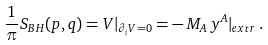<formula> <loc_0><loc_0><loc_500><loc_500>\frac { 1 } { \pi } S _ { B H } ( p , q ) = V | _ { \partial _ { i } V = 0 } = - \, M _ { A } \, y ^ { A } | _ { e x t r } \, .</formula> 